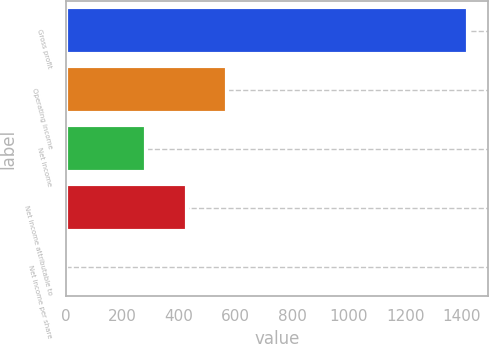Convert chart. <chart><loc_0><loc_0><loc_500><loc_500><bar_chart><fcel>Gross profit<fcel>Operating income<fcel>Net income<fcel>Net income attributable to<fcel>Net income per share<nl><fcel>1422<fcel>569.04<fcel>284.72<fcel>426.88<fcel>0.4<nl></chart> 